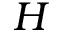Convert formula to latex. <formula><loc_0><loc_0><loc_500><loc_500>H</formula> 